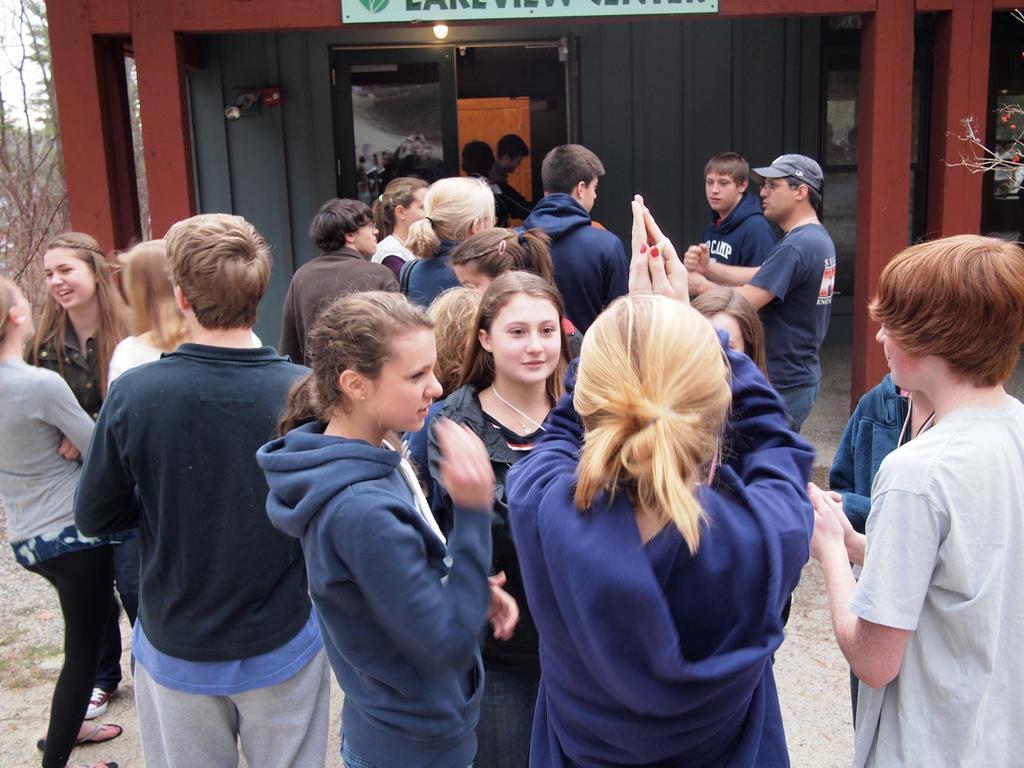Can you describe this image briefly? In the center of the image we can see many people standing. In the background there is a shed and we can see trees. 